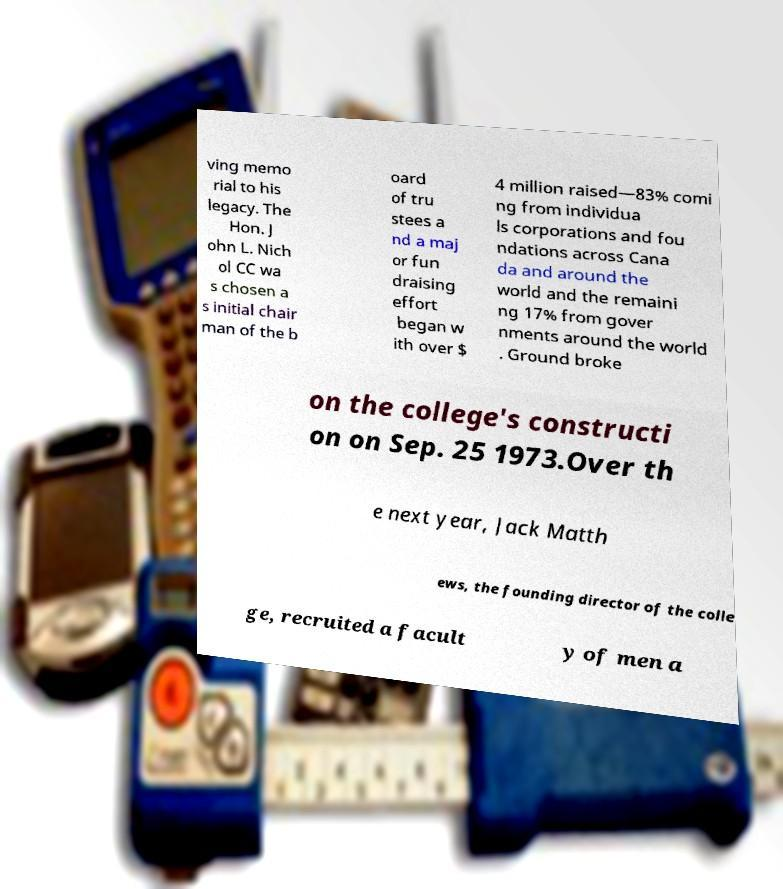Please read and relay the text visible in this image. What does it say? ving memo rial to his legacy. The Hon. J ohn L. Nich ol CC wa s chosen a s initial chair man of the b oard of tru stees a nd a maj or fun draising effort began w ith over $ 4 million raised—83% comi ng from individua ls corporations and fou ndations across Cana da and around the world and the remaini ng 17% from gover nments around the world . Ground broke on the college's constructi on on Sep. 25 1973.Over th e next year, Jack Matth ews, the founding director of the colle ge, recruited a facult y of men a 